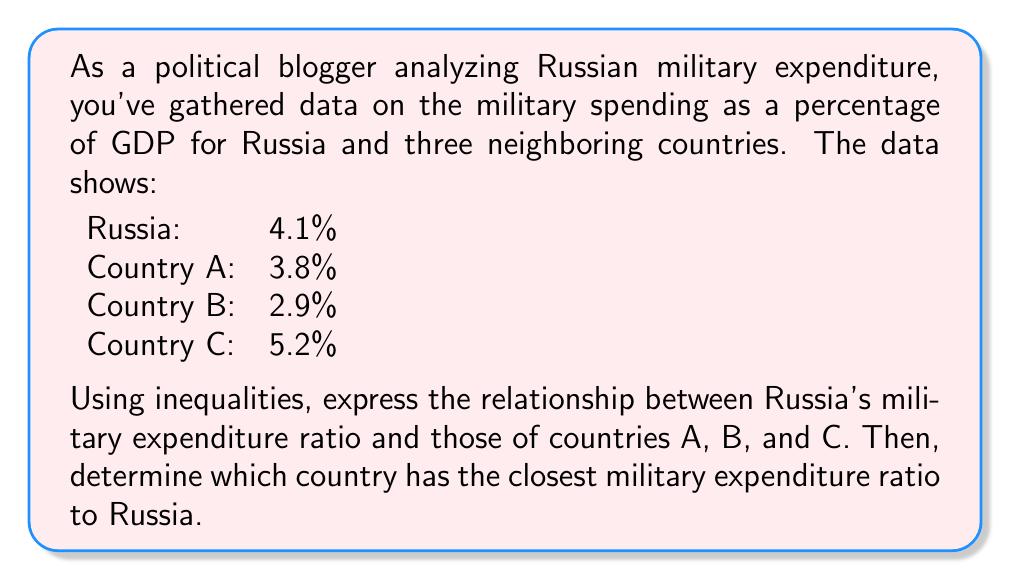Solve this math problem. Let's approach this step-by-step:

1) First, we need to express the relationships using inequalities. Let's denote Russia's military expenditure ratio as $R$.

   For Country A: $R > 3.8\%$
   For Country B: $R > 2.9\%$
   For Country C: $R < 5.2\%$

2) Combining these inequalities, we get:
   
   $2.9\% < R < 5.2\%$

3) To determine which country has the closest military expenditure ratio to Russia, we need to calculate the absolute difference between Russia's ratio and each country's ratio:

   Country A: $|4.1\% - 3.8\%| = 0.3\%$
   Country B: $|4.1\% - 2.9\%| = 1.2\%$
   Country C: $|4.1\% - 5.2\%| = 1.1\%$

4) The smallest difference indicates the closest ratio. In this case, it's Country A with a difference of 0.3%.
Answer: The relationship between Russia's military expenditure ratio ($R$) and those of countries A, B, and C can be expressed as:

$2.9\% < R < 5.2\%$

Country A has the closest military expenditure ratio to Russia. 